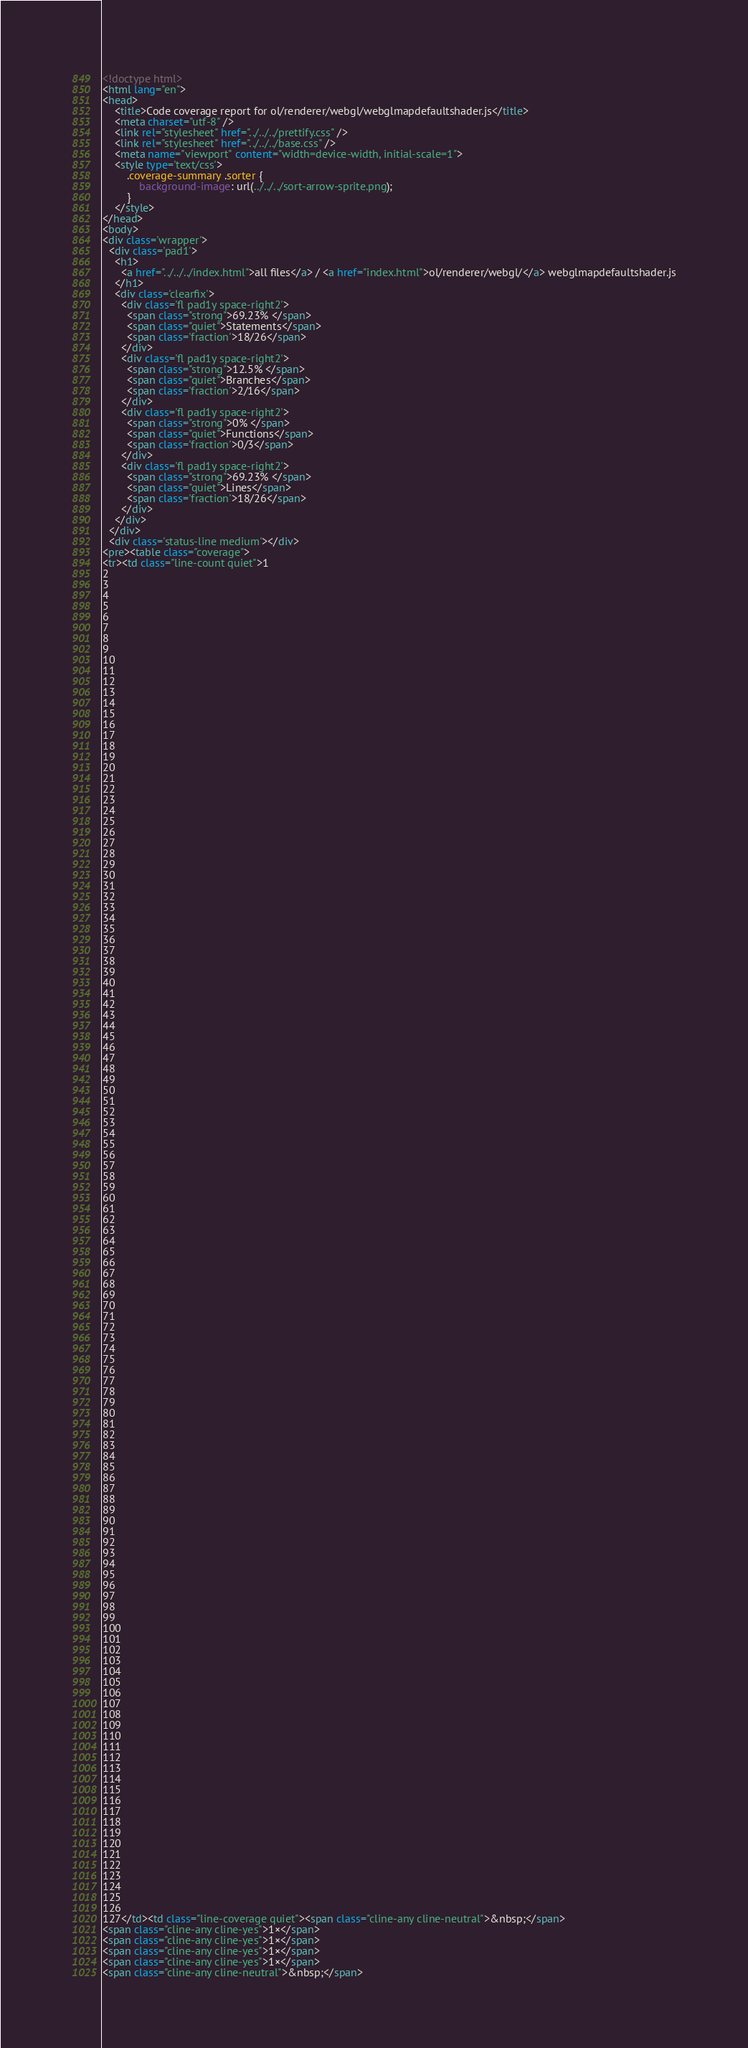Convert code to text. <code><loc_0><loc_0><loc_500><loc_500><_HTML_><!doctype html>
<html lang="en">
<head>
    <title>Code coverage report for ol/renderer/webgl/webglmapdefaultshader.js</title>
    <meta charset="utf-8" />
    <link rel="stylesheet" href="../../../prettify.css" />
    <link rel="stylesheet" href="../../../base.css" />
    <meta name="viewport" content="width=device-width, initial-scale=1">
    <style type='text/css'>
        .coverage-summary .sorter {
            background-image: url(../../../sort-arrow-sprite.png);
        }
    </style>
</head>
<body>
<div class='wrapper'>
  <div class='pad1'>
    <h1>
      <a href="../../../index.html">all files</a> / <a href="index.html">ol/renderer/webgl/</a> webglmapdefaultshader.js
    </h1>
    <div class='clearfix'>
      <div class='fl pad1y space-right2'>
        <span class="strong">69.23% </span>
        <span class="quiet">Statements</span>
        <span class='fraction'>18/26</span>
      </div>
      <div class='fl pad1y space-right2'>
        <span class="strong">12.5% </span>
        <span class="quiet">Branches</span>
        <span class='fraction'>2/16</span>
      </div>
      <div class='fl pad1y space-right2'>
        <span class="strong">0% </span>
        <span class="quiet">Functions</span>
        <span class='fraction'>0/3</span>
      </div>
      <div class='fl pad1y space-right2'>
        <span class="strong">69.23% </span>
        <span class="quiet">Lines</span>
        <span class='fraction'>18/26</span>
      </div>
    </div>
  </div>
  <div class='status-line medium'></div>
<pre><table class="coverage">
<tr><td class="line-count quiet">1
2
3
4
5
6
7
8
9
10
11
12
13
14
15
16
17
18
19
20
21
22
23
24
25
26
27
28
29
30
31
32
33
34
35
36
37
38
39
40
41
42
43
44
45
46
47
48
49
50
51
52
53
54
55
56
57
58
59
60
61
62
63
64
65
66
67
68
69
70
71
72
73
74
75
76
77
78
79
80
81
82
83
84
85
86
87
88
89
90
91
92
93
94
95
96
97
98
99
100
101
102
103
104
105
106
107
108
109
110
111
112
113
114
115
116
117
118
119
120
121
122
123
124
125
126
127</td><td class="line-coverage quiet"><span class="cline-any cline-neutral">&nbsp;</span>
<span class="cline-any cline-yes">1×</span>
<span class="cline-any cline-yes">1×</span>
<span class="cline-any cline-yes">1×</span>
<span class="cline-any cline-yes">1×</span>
<span class="cline-any cline-neutral">&nbsp;</span></code> 